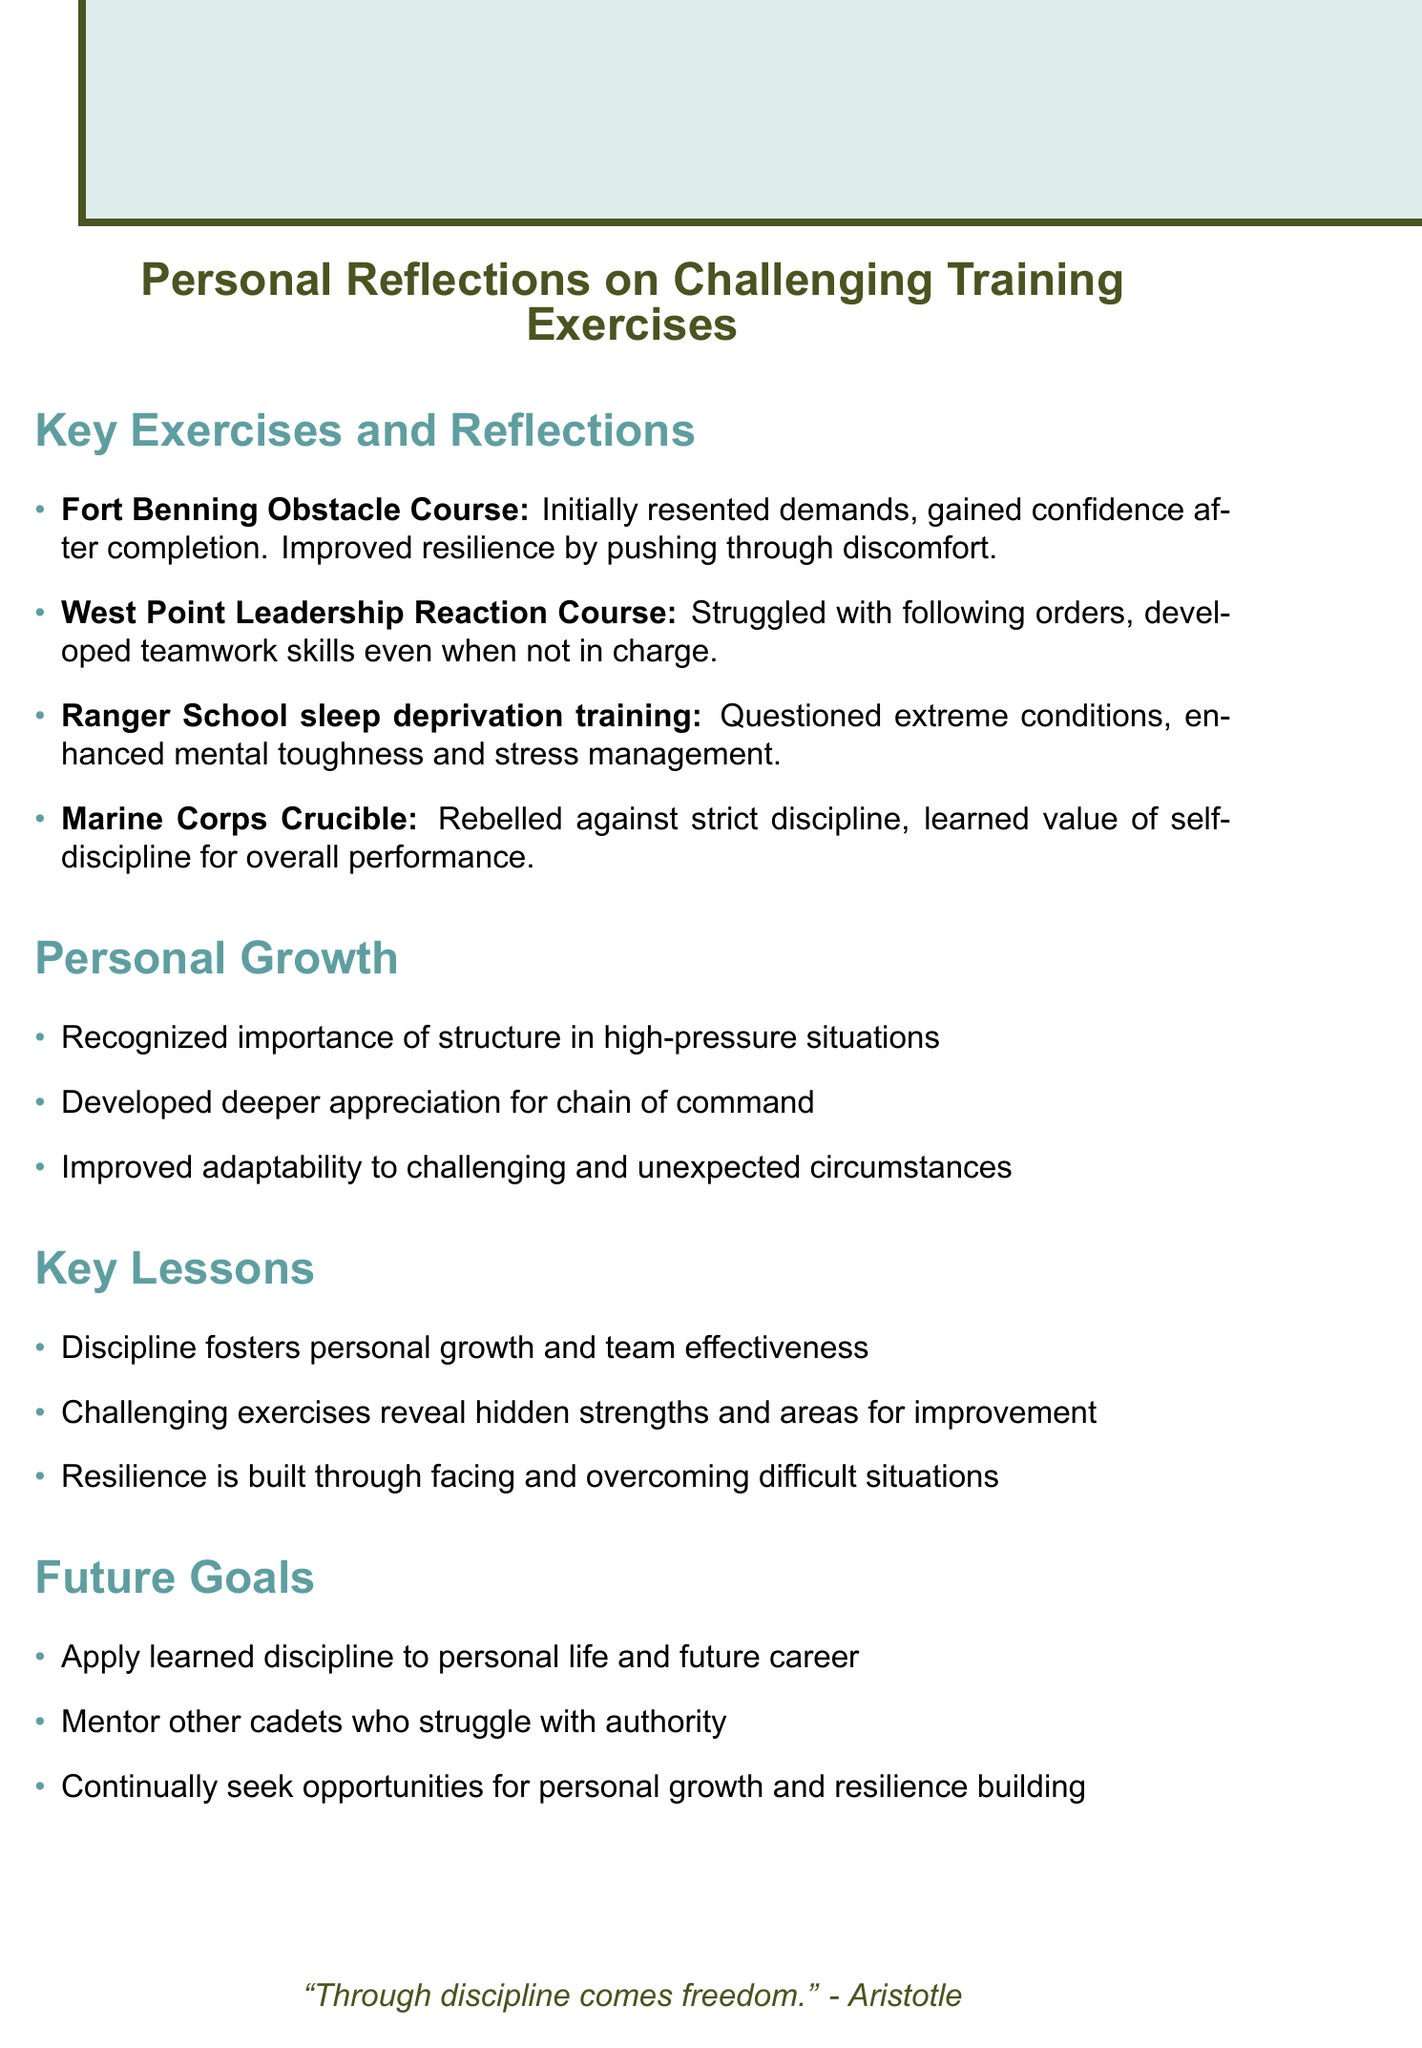What exercise is mentioned first? The first exercise listed in the document is the Fort Benning Obstacle Course.
Answer: Fort Benning Obstacle Course What improvement did I gain from the Ranger School sleep deprivation training? It states that I enhanced mental toughness and stress management from this training.
Answer: Enhanced mental toughness and stress management What is one personal growth realization mentioned? One realization is that there is an importance of structure in high-pressure situations.
Answer: Importance of structure in high-pressure situations What is a key lesson about discipline? The document states that discipline fosters personal growth and team effectiveness.
Answer: Discipline fosters personal growth and team effectiveness What is one of the future goals listed? One of the future goals is to mentor other cadets who struggle with authority.
Answer: Mentor other cadets who struggle with authority What was the initial reaction to the Marine Corps Crucible? The initial reaction was a rebellion against the strict discipline required.
Answer: Rebelled against strict discipline Which course focused on teamwork despite not being in charge? The West Point Leadership Reaction Course focused on developing teamwork under these conditions.
Answer: West Point Leadership Reaction Course What quote is included at the end of the document? The quote at the end is a saying by Aristotle regarding discipline.
Answer: "Through discipline comes freedom." 